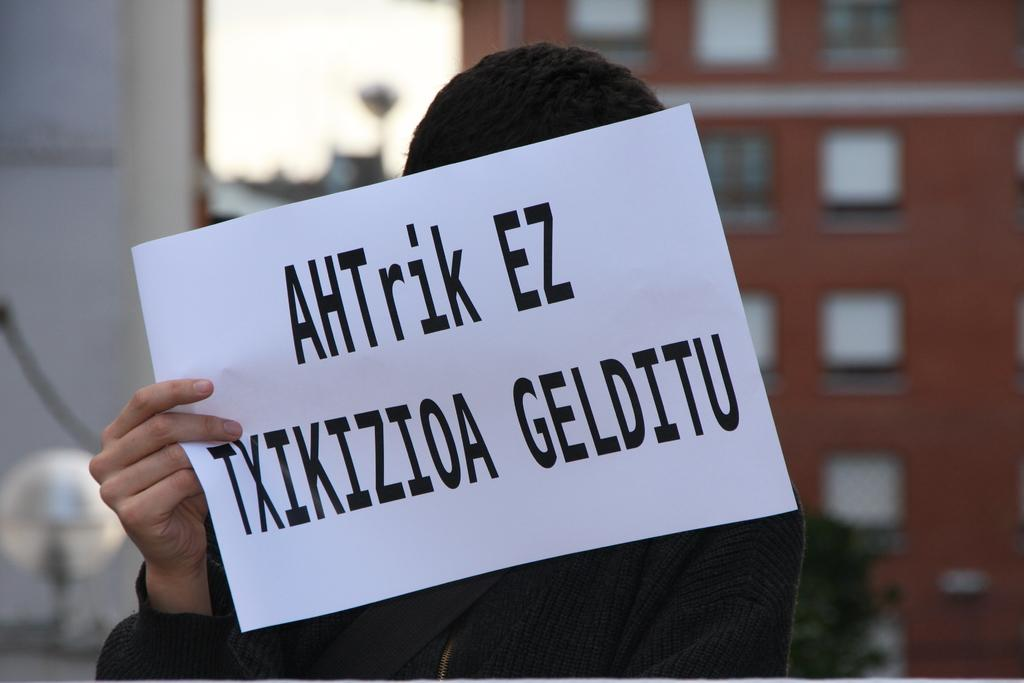Who is the main subject in the image? There is a woman in the image. What is the woman wearing? The woman is wearing a sweater. What is the woman holding in the image? The woman is holding a paper. What can be seen in the background of the image? There are buildings in the background of the image. What is visible at the top of the image? The sky is visible at the top of the image. What country is the woman giving birth to in the image? There is no indication of the woman giving birth or any country in the image. 